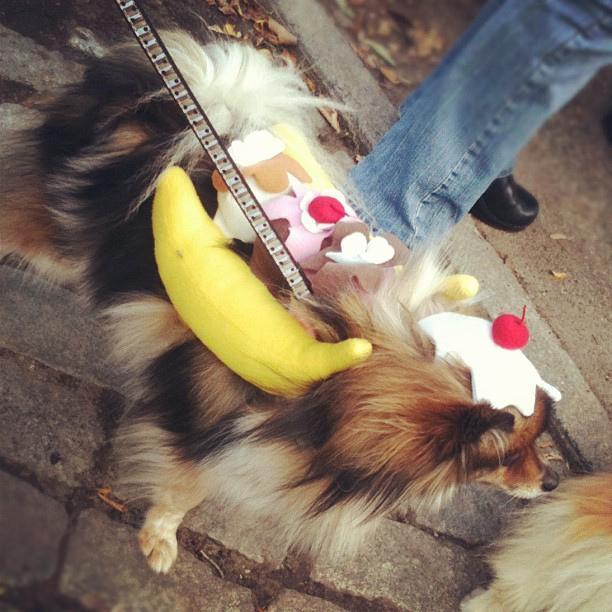How many dogs can you see?
Give a very brief answer. 2. How many orange signs are on the street?
Give a very brief answer. 0. 